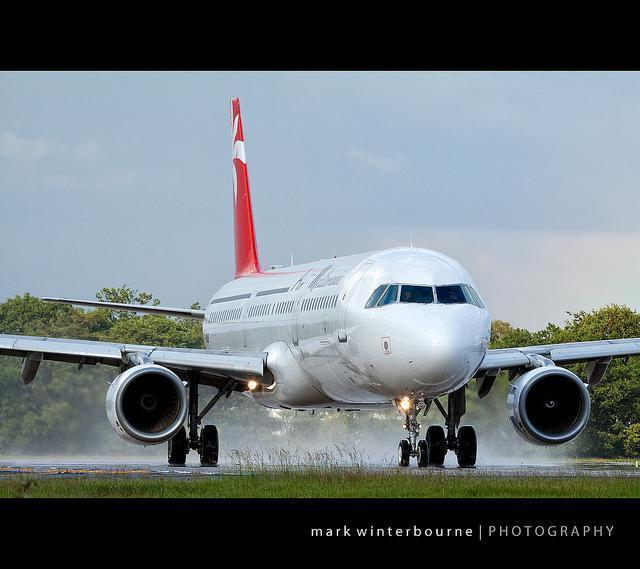How many lights can you see on the plane?
Give a very brief answer. 2. How many people are to the left of the hydrant?
Give a very brief answer. 0. 